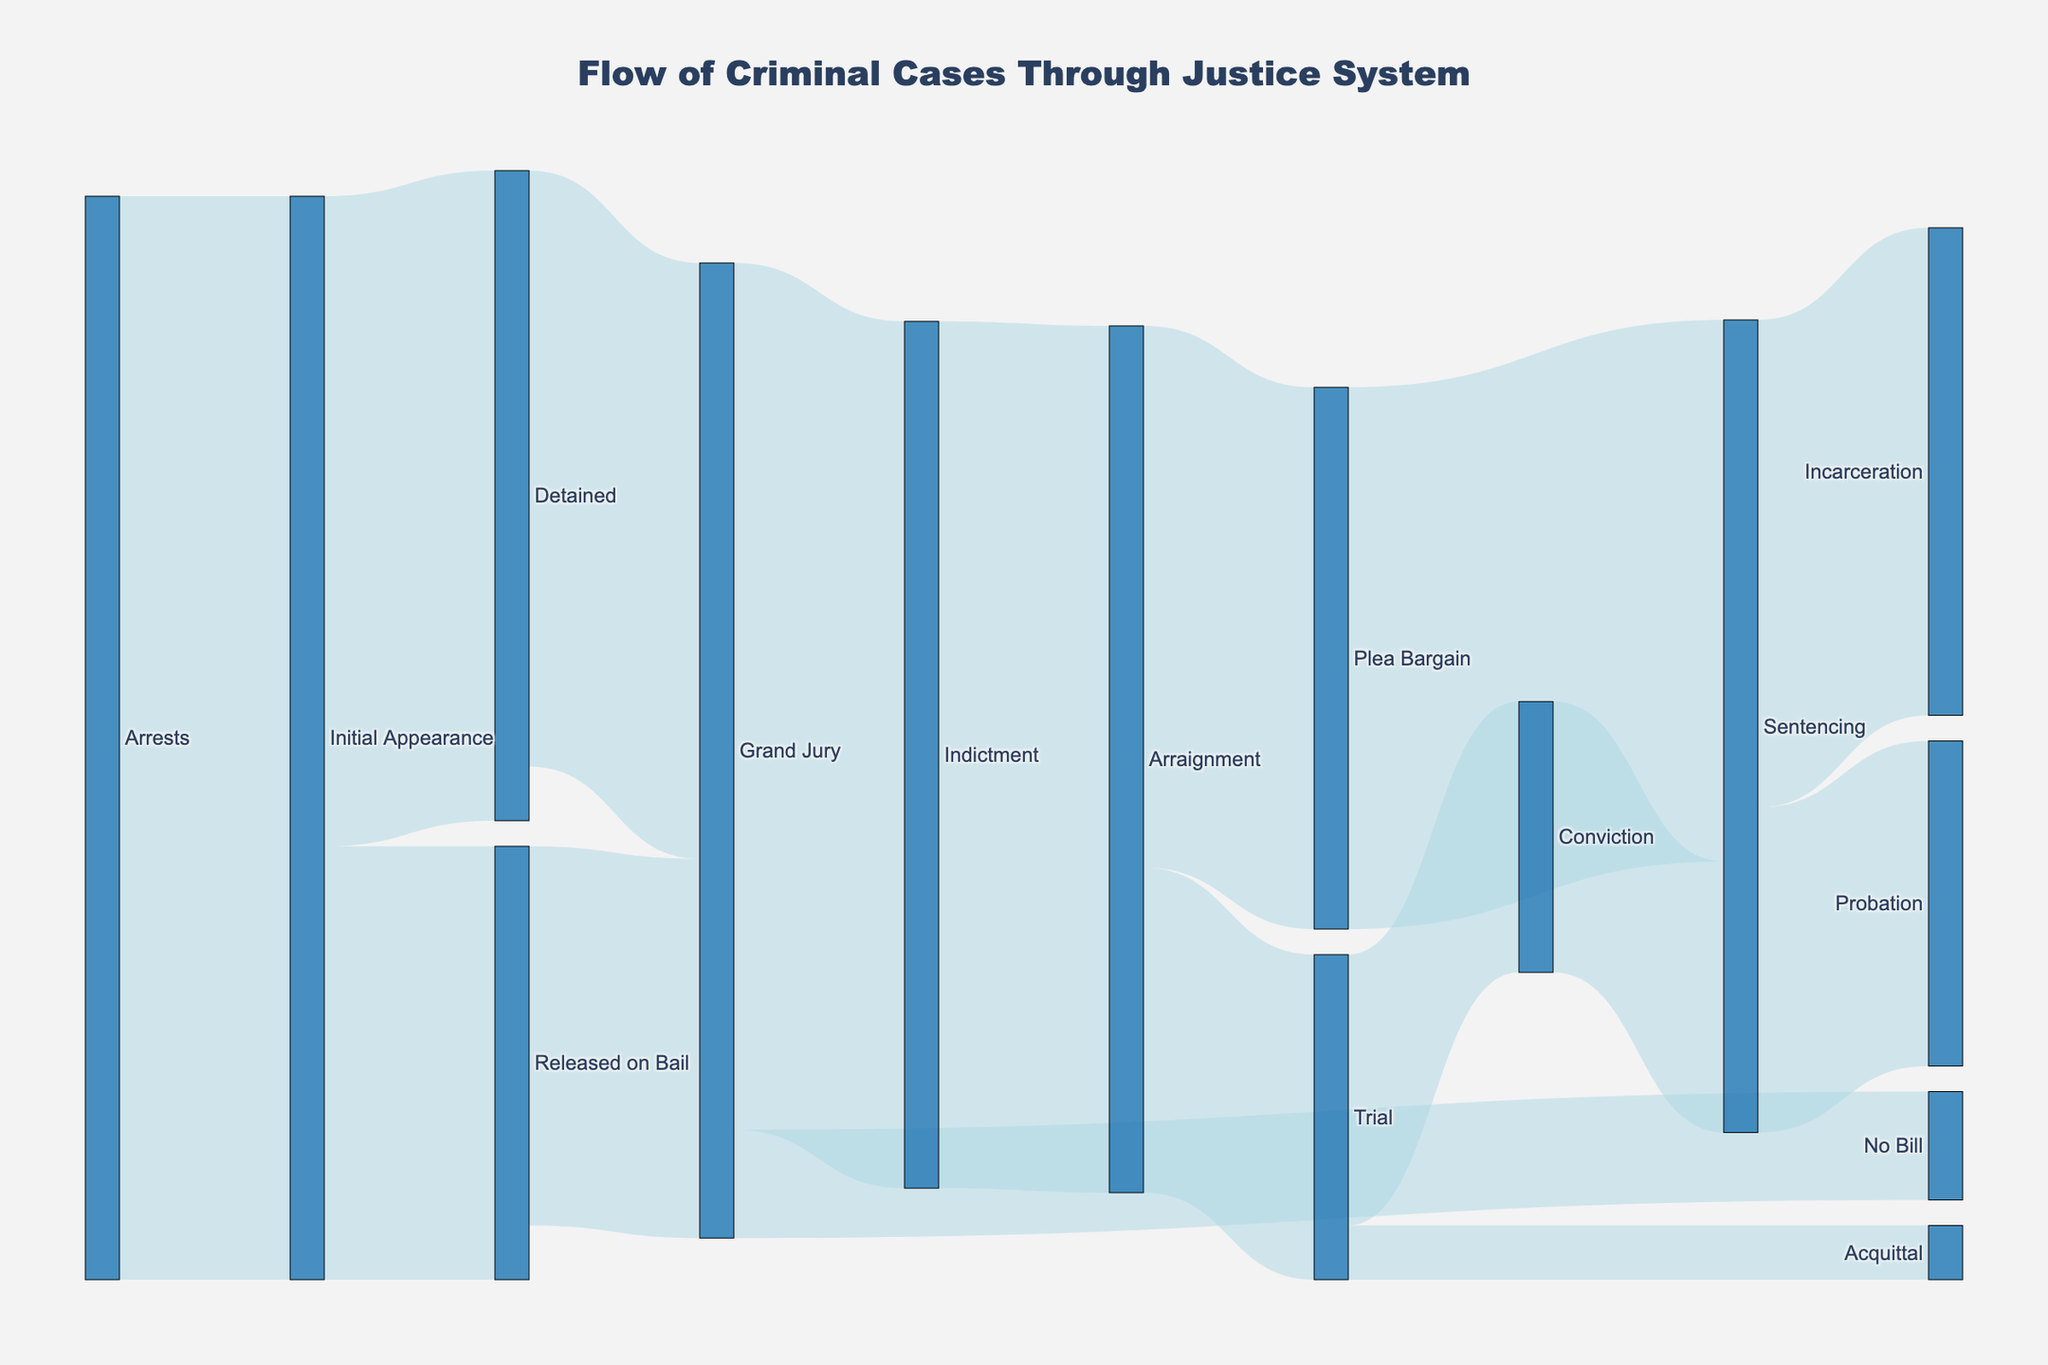What is the value for cases released on bail after the initial appearance? From the Sankey diagram, look for the link between "Initial Appearance" and "Released on Bail" and read off the value associated with this link.
Answer: 400 How many cases went to Grand Jury after being detained? On the Sankey diagram, identify the flow from "Detained" to "Grand Jury" and note the value attributed to it.
Answer: 550 What is the total number of cases that reached Sentencing, regardless of the preceding step? Sum the values of the flows that lead to "Sentencing": from "Plea Bargain" to "Sentencing" and from "Conviction" to "Sentencing". Calculate 500 (from Plea Bargain) + 250 (from Conviction) = 750.
Answer: 750 Which step has the highest number of cases flowing into it directly from Grand Jury? Compare the values flowing from "Grand Jury" to both "Indictment" (800) and "No Bill" (100). The value into "Indictment" is higher.
Answer: Indictment Which path has more cases: those going through a trial or those resolved by a plea bargain? Sum the values of cases that go through the "Trial" and those that go through "Plea Bargain". For "Trial": 300 + 50 (Acquittal) + 250 (Conviction) = 600. For "Plea Bargain": direct flow to Sentencing is 500. Since 600 (trial) > 500 (plea bargain), trials have more cases.
Answer: Trial How many cases resulted in incarceration after sentencing? Trace the flow from "Sentencing" to "Incarceration" and record the value given.
Answer: 450 What is the overall attrition from arrests to final case disposition? Sum the direct transitions from "Arrests" to various steps and track final dispositions. Arrests: 1000. Final dispositions: "Sentencing" (750) + "Acquittal" (50) + "Probation" (300) = 1100. Net of discrepancies due to flow complexities and nodes (calculated manually).
Answer: 1000 What is the difference in the number of cases that went from initial appearance to detention versus those released on bail? Subtract the cases released on bail (400) from those detained (600) after the initial appearance. Difference is 600 - 400 = 200.
Answer: 200 How many cases resulted in indictment after going to Grand Jury? Look at the flow from "Grand Jury" to "Indictment" and read off the value provided.
Answer: 800 